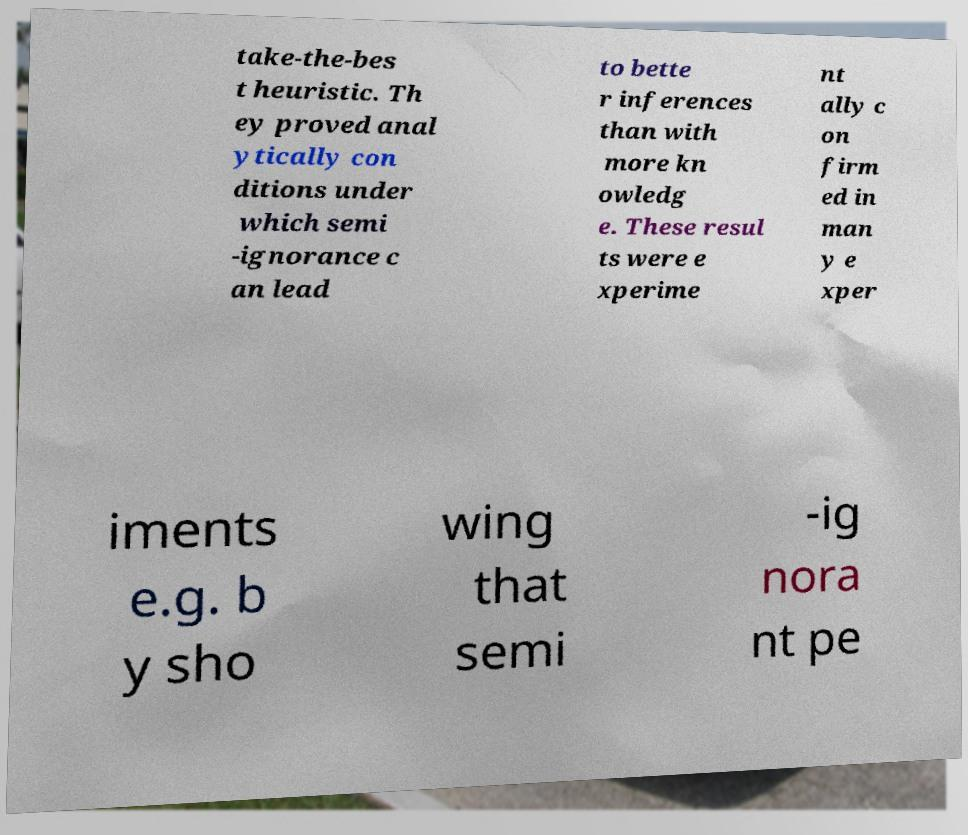Could you extract and type out the text from this image? take-the-bes t heuristic. Th ey proved anal ytically con ditions under which semi -ignorance c an lead to bette r inferences than with more kn owledg e. These resul ts were e xperime nt ally c on firm ed in man y e xper iments e.g. b y sho wing that semi -ig nora nt pe 